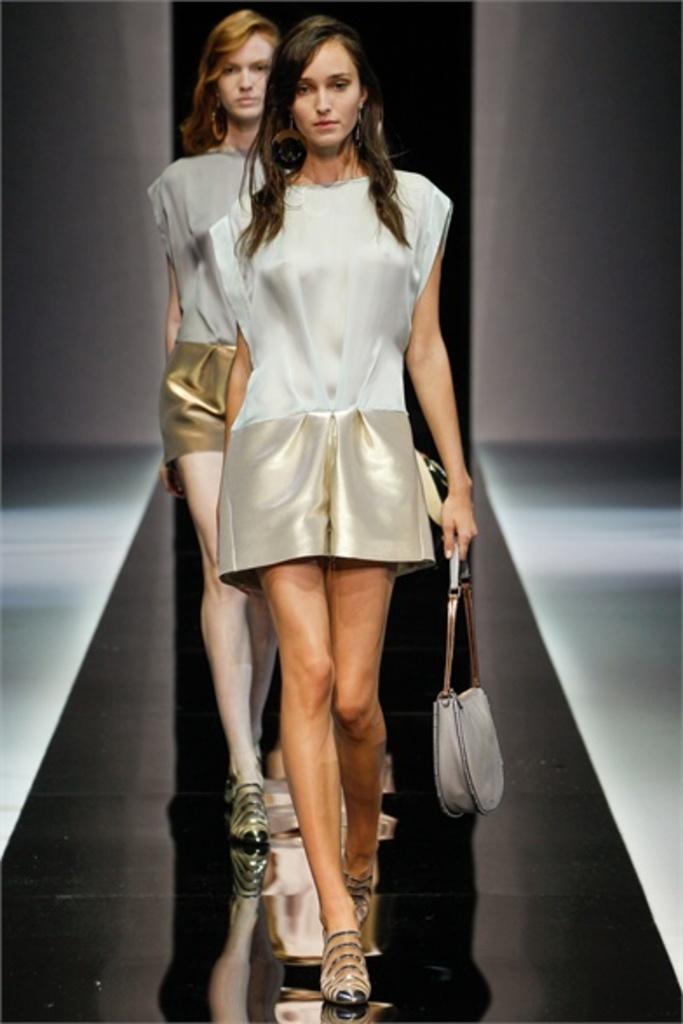How would you summarize this image in a sentence or two? Here we can see a couple of woman walking on the ramp with a handbag in their hand 